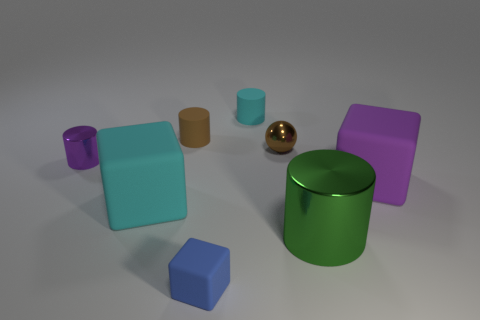Add 1 gray metal cylinders. How many objects exist? 9 Subtract all balls. How many objects are left? 7 Subtract all blue objects. Subtract all tiny cyan matte objects. How many objects are left? 6 Add 8 big purple rubber cubes. How many big purple rubber cubes are left? 9 Add 7 small blue blocks. How many small blue blocks exist? 8 Subtract 0 purple spheres. How many objects are left? 8 